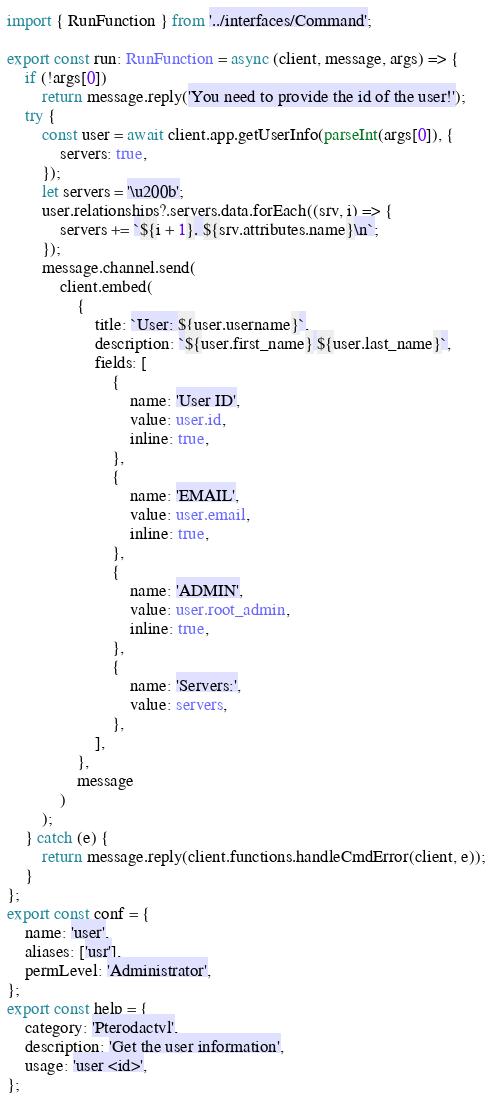Convert code to text. <code><loc_0><loc_0><loc_500><loc_500><_TypeScript_>import { RunFunction } from '../interfaces/Command';

export const run: RunFunction = async (client, message, args) => {
    if (!args[0])
        return message.reply('You need to provide the id of the user!');
    try {
        const user = await client.app.getUserInfo(parseInt(args[0]), {
            servers: true,
        });
        let servers = '\u200b';
        user.relationships?.servers.data.forEach((srv, i) => {
            servers += `${i + 1}. ${srv.attributes.name}\n`;
        });
        message.channel.send(
            client.embed(
                {
                    title: `User: ${user.username}`,
                    description: `${user.first_name} ${user.last_name}`,
                    fields: [
                        {
                            name: 'User ID',
                            value: user.id,
                            inline: true,
                        },
                        {
                            name: 'EMAIL',
                            value: user.email,
                            inline: true,
                        },
                        {
                            name: 'ADMIN',
                            value: user.root_admin,
                            inline: true,
                        },
                        {
                            name: 'Servers:',
                            value: servers,
                        },
                    ],
                },
                message
            )
        );
    } catch (e) {
        return message.reply(client.functions.handleCmdError(client, e));
    }
};
export const conf = {
    name: 'user',
    aliases: ['usr'],
    permLevel: 'Administrator',
};
export const help = {
    category: 'Pterodactyl',
    description: 'Get the user information',
    usage: 'user <id>',
};
</code> 